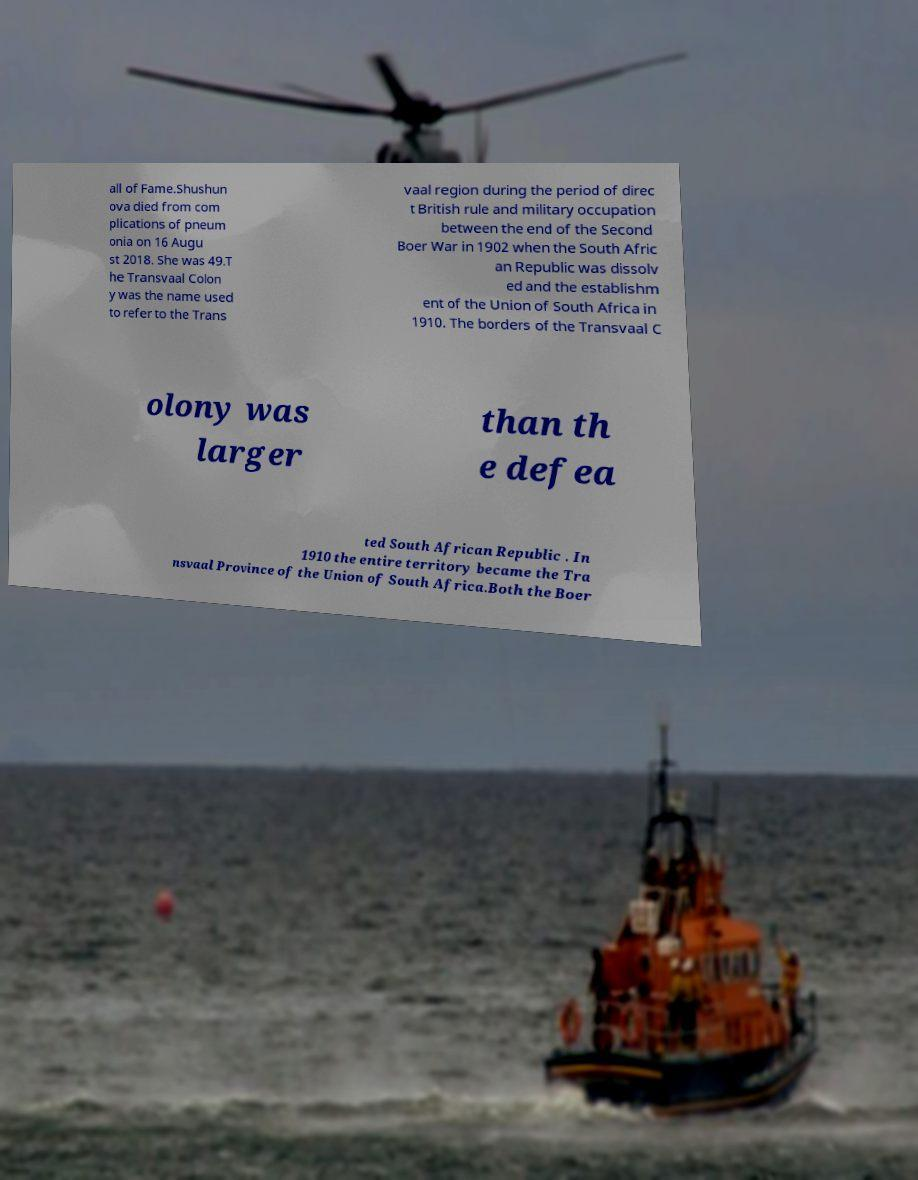What messages or text are displayed in this image? I need them in a readable, typed format. all of Fame.Shushun ova died from com plications of pneum onia on 16 Augu st 2018. She was 49.T he Transvaal Colon y was the name used to refer to the Trans vaal region during the period of direc t British rule and military occupation between the end of the Second Boer War in 1902 when the South Afric an Republic was dissolv ed and the establishm ent of the Union of South Africa in 1910. The borders of the Transvaal C olony was larger than th e defea ted South African Republic . In 1910 the entire territory became the Tra nsvaal Province of the Union of South Africa.Both the Boer 